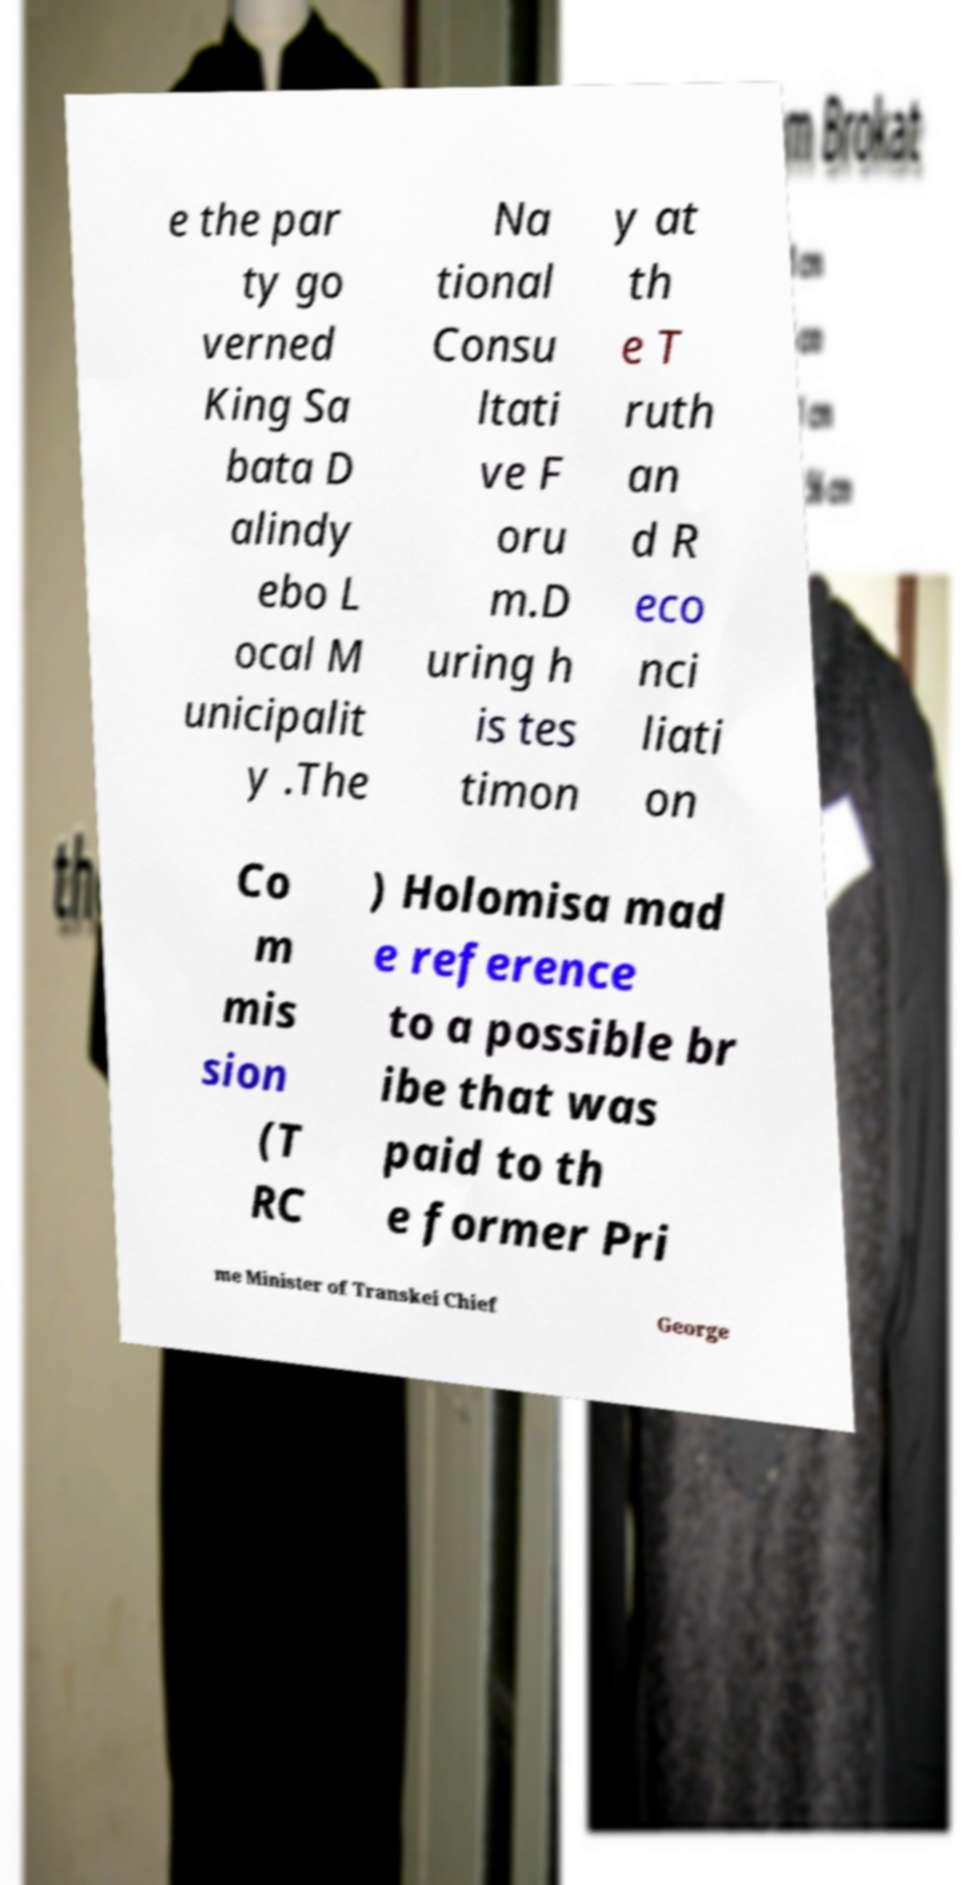I need the written content from this picture converted into text. Can you do that? e the par ty go verned King Sa bata D alindy ebo L ocal M unicipalit y .The Na tional Consu ltati ve F oru m.D uring h is tes timon y at th e T ruth an d R eco nci liati on Co m mis sion (T RC ) Holomisa mad e reference to a possible br ibe that was paid to th e former Pri me Minister of Transkei Chief George 